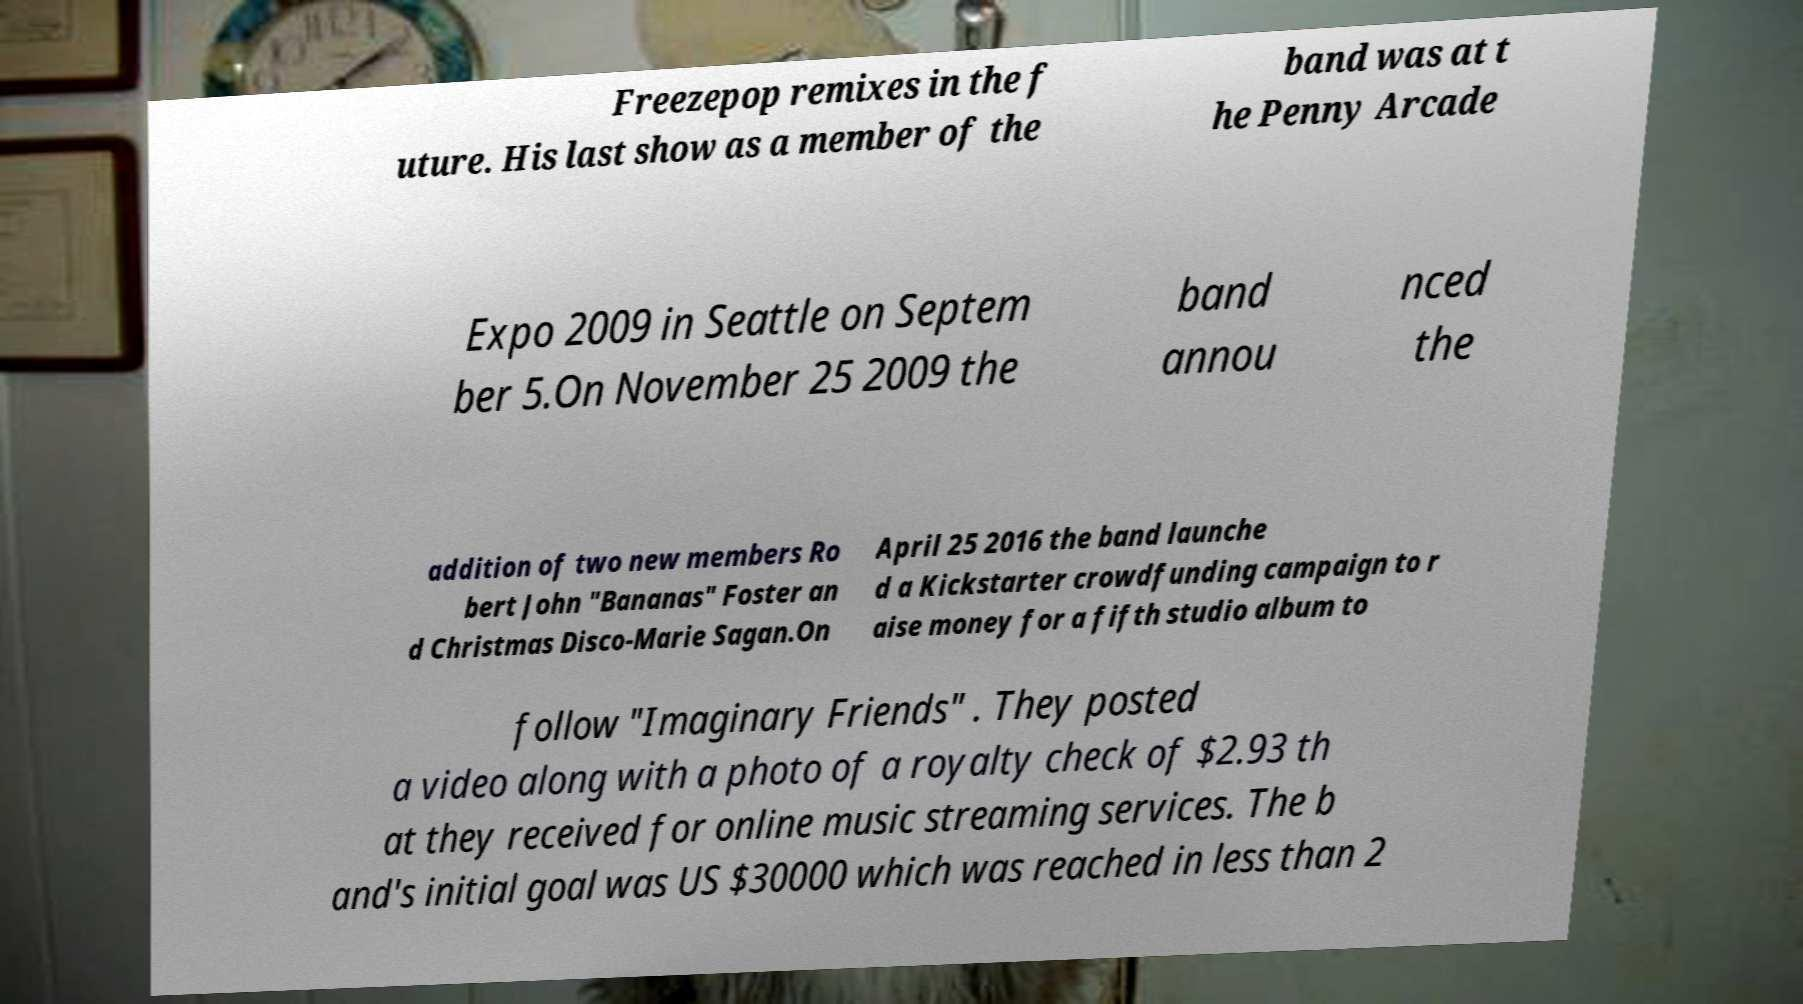Can you accurately transcribe the text from the provided image for me? Freezepop remixes in the f uture. His last show as a member of the band was at t he Penny Arcade Expo 2009 in Seattle on Septem ber 5.On November 25 2009 the band annou nced the addition of two new members Ro bert John "Bananas" Foster an d Christmas Disco-Marie Sagan.On April 25 2016 the band launche d a Kickstarter crowdfunding campaign to r aise money for a fifth studio album to follow "Imaginary Friends" . They posted a video along with a photo of a royalty check of $2.93 th at they received for online music streaming services. The b and's initial goal was US $30000 which was reached in less than 2 